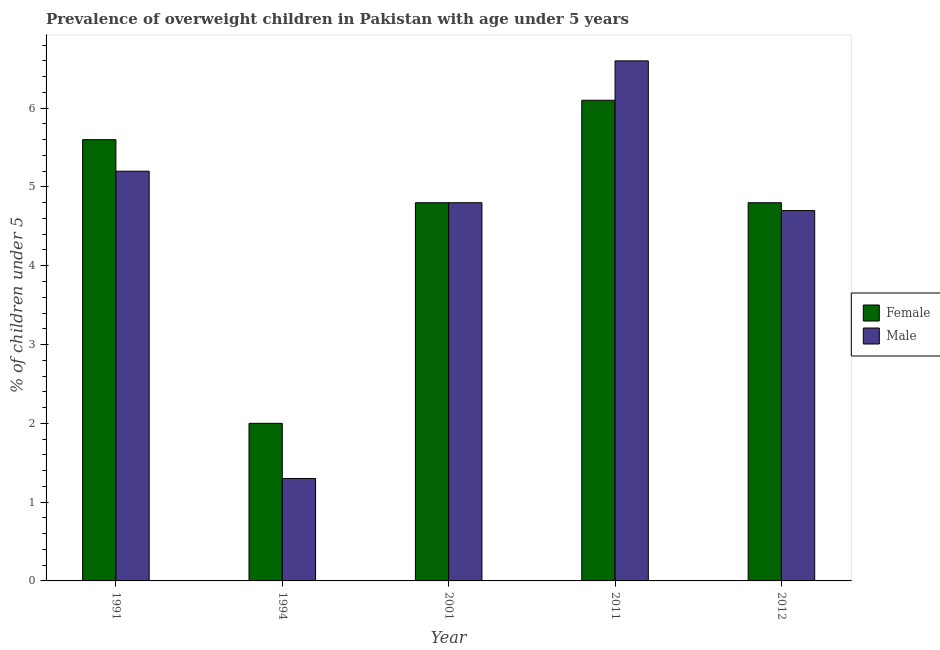How many different coloured bars are there?
Provide a succinct answer. 2. Are the number of bars on each tick of the X-axis equal?
Make the answer very short. Yes. In how many cases, is the number of bars for a given year not equal to the number of legend labels?
Provide a succinct answer. 0. What is the percentage of obese male children in 1991?
Provide a succinct answer. 5.2. Across all years, what is the maximum percentage of obese female children?
Provide a short and direct response. 6.1. In which year was the percentage of obese female children minimum?
Your response must be concise. 1994. What is the total percentage of obese male children in the graph?
Provide a short and direct response. 22.6. What is the difference between the percentage of obese male children in 2001 and that in 2012?
Your response must be concise. 0.1. What is the average percentage of obese female children per year?
Give a very brief answer. 4.66. In the year 2012, what is the difference between the percentage of obese female children and percentage of obese male children?
Keep it short and to the point. 0. What is the ratio of the percentage of obese female children in 1994 to that in 2012?
Ensure brevity in your answer.  0.42. Is the percentage of obese male children in 1994 less than that in 2001?
Keep it short and to the point. Yes. Is the difference between the percentage of obese male children in 2011 and 2012 greater than the difference between the percentage of obese female children in 2011 and 2012?
Your answer should be compact. No. What is the difference between the highest and the lowest percentage of obese male children?
Your response must be concise. 5.3. What does the 1st bar from the right in 1994 represents?
Your answer should be compact. Male. How many years are there in the graph?
Provide a short and direct response. 5. What is the difference between two consecutive major ticks on the Y-axis?
Provide a succinct answer. 1. Does the graph contain grids?
Give a very brief answer. No. Where does the legend appear in the graph?
Offer a very short reply. Center right. How many legend labels are there?
Offer a terse response. 2. What is the title of the graph?
Your answer should be compact. Prevalence of overweight children in Pakistan with age under 5 years. What is the label or title of the Y-axis?
Your answer should be compact.  % of children under 5. What is the  % of children under 5 of Female in 1991?
Offer a very short reply. 5.6. What is the  % of children under 5 of Male in 1991?
Your answer should be compact. 5.2. What is the  % of children under 5 of Female in 1994?
Your answer should be compact. 2. What is the  % of children under 5 in Male in 1994?
Your answer should be very brief. 1.3. What is the  % of children under 5 of Female in 2001?
Keep it short and to the point. 4.8. What is the  % of children under 5 of Male in 2001?
Your answer should be very brief. 4.8. What is the  % of children under 5 in Female in 2011?
Your answer should be very brief. 6.1. What is the  % of children under 5 in Male in 2011?
Your answer should be very brief. 6.6. What is the  % of children under 5 of Female in 2012?
Offer a terse response. 4.8. What is the  % of children under 5 in Male in 2012?
Your response must be concise. 4.7. Across all years, what is the maximum  % of children under 5 of Female?
Your answer should be compact. 6.1. Across all years, what is the maximum  % of children under 5 in Male?
Your answer should be very brief. 6.6. Across all years, what is the minimum  % of children under 5 of Female?
Offer a very short reply. 2. Across all years, what is the minimum  % of children under 5 in Male?
Your answer should be very brief. 1.3. What is the total  % of children under 5 of Female in the graph?
Make the answer very short. 23.3. What is the total  % of children under 5 in Male in the graph?
Your answer should be very brief. 22.6. What is the difference between the  % of children under 5 of Female in 1991 and that in 1994?
Your answer should be compact. 3.6. What is the difference between the  % of children under 5 of Male in 1991 and that in 1994?
Ensure brevity in your answer.  3.9. What is the difference between the  % of children under 5 in Female in 1991 and that in 2001?
Make the answer very short. 0.8. What is the difference between the  % of children under 5 of Male in 1991 and that in 2001?
Give a very brief answer. 0.4. What is the difference between the  % of children under 5 in Male in 1991 and that in 2011?
Provide a short and direct response. -1.4. What is the difference between the  % of children under 5 of Female in 1991 and that in 2012?
Keep it short and to the point. 0.8. What is the difference between the  % of children under 5 of Male in 1991 and that in 2012?
Your response must be concise. 0.5. What is the difference between the  % of children under 5 of Male in 1994 and that in 2001?
Keep it short and to the point. -3.5. What is the difference between the  % of children under 5 in Female in 1994 and that in 2011?
Make the answer very short. -4.1. What is the difference between the  % of children under 5 of Male in 1994 and that in 2012?
Your answer should be very brief. -3.4. What is the difference between the  % of children under 5 of Female in 2001 and that in 2012?
Your response must be concise. 0. What is the difference between the  % of children under 5 in Male in 2001 and that in 2012?
Make the answer very short. 0.1. What is the difference between the  % of children under 5 in Female in 2011 and that in 2012?
Your answer should be very brief. 1.3. What is the difference between the  % of children under 5 in Male in 2011 and that in 2012?
Your answer should be very brief. 1.9. What is the difference between the  % of children under 5 of Female in 1991 and the  % of children under 5 of Male in 2012?
Provide a succinct answer. 0.9. What is the difference between the  % of children under 5 in Female in 1994 and the  % of children under 5 in Male in 2012?
Ensure brevity in your answer.  -2.7. What is the difference between the  % of children under 5 in Female in 2001 and the  % of children under 5 in Male in 2012?
Your answer should be very brief. 0.1. What is the average  % of children under 5 of Female per year?
Offer a very short reply. 4.66. What is the average  % of children under 5 in Male per year?
Offer a terse response. 4.52. In the year 1991, what is the difference between the  % of children under 5 of Female and  % of children under 5 of Male?
Provide a succinct answer. 0.4. In the year 2001, what is the difference between the  % of children under 5 in Female and  % of children under 5 in Male?
Ensure brevity in your answer.  0. In the year 2012, what is the difference between the  % of children under 5 of Female and  % of children under 5 of Male?
Offer a terse response. 0.1. What is the ratio of the  % of children under 5 in Female in 1991 to that in 1994?
Provide a short and direct response. 2.8. What is the ratio of the  % of children under 5 of Female in 1991 to that in 2011?
Provide a short and direct response. 0.92. What is the ratio of the  % of children under 5 in Male in 1991 to that in 2011?
Provide a succinct answer. 0.79. What is the ratio of the  % of children under 5 of Male in 1991 to that in 2012?
Provide a short and direct response. 1.11. What is the ratio of the  % of children under 5 in Female in 1994 to that in 2001?
Your answer should be very brief. 0.42. What is the ratio of the  % of children under 5 in Male in 1994 to that in 2001?
Your response must be concise. 0.27. What is the ratio of the  % of children under 5 of Female in 1994 to that in 2011?
Offer a terse response. 0.33. What is the ratio of the  % of children under 5 of Male in 1994 to that in 2011?
Your response must be concise. 0.2. What is the ratio of the  % of children under 5 of Female in 1994 to that in 2012?
Provide a short and direct response. 0.42. What is the ratio of the  % of children under 5 in Male in 1994 to that in 2012?
Provide a succinct answer. 0.28. What is the ratio of the  % of children under 5 of Female in 2001 to that in 2011?
Give a very brief answer. 0.79. What is the ratio of the  % of children under 5 in Male in 2001 to that in 2011?
Keep it short and to the point. 0.73. What is the ratio of the  % of children under 5 of Male in 2001 to that in 2012?
Make the answer very short. 1.02. What is the ratio of the  % of children under 5 in Female in 2011 to that in 2012?
Your answer should be compact. 1.27. What is the ratio of the  % of children under 5 in Male in 2011 to that in 2012?
Your answer should be compact. 1.4. What is the difference between the highest and the second highest  % of children under 5 in Female?
Give a very brief answer. 0.5. What is the difference between the highest and the lowest  % of children under 5 of Male?
Keep it short and to the point. 5.3. 